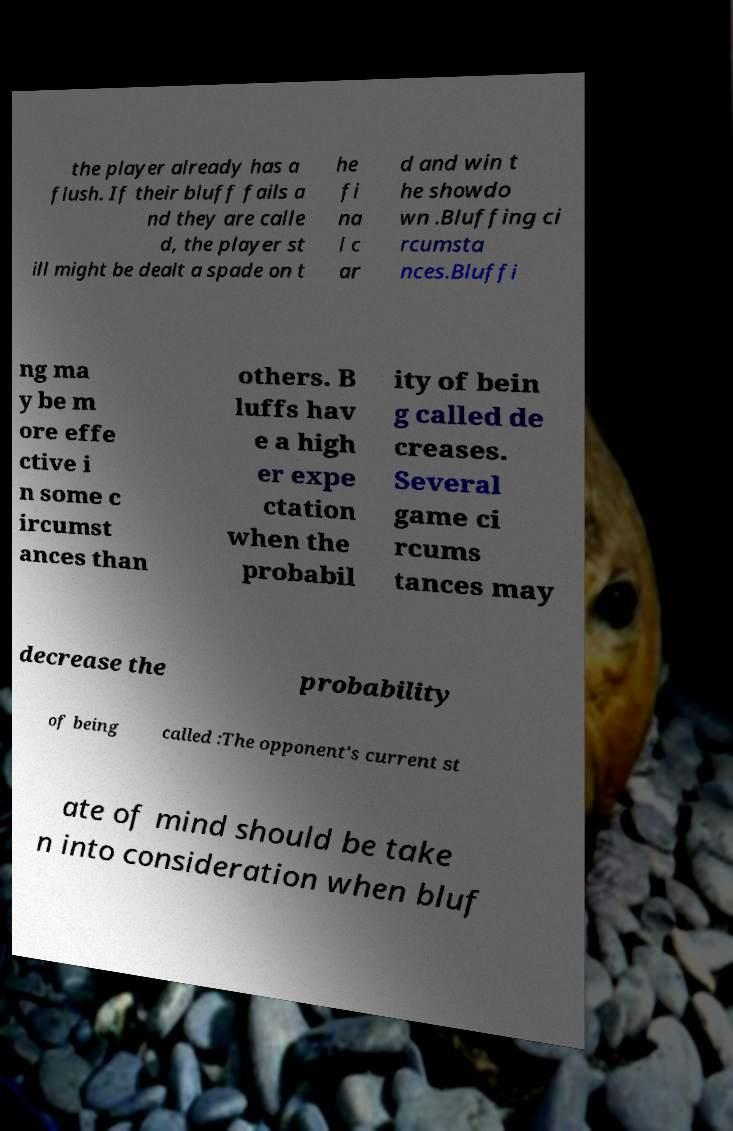Can you read and provide the text displayed in the image?This photo seems to have some interesting text. Can you extract and type it out for me? the player already has a flush. If their bluff fails a nd they are calle d, the player st ill might be dealt a spade on t he fi na l c ar d and win t he showdo wn .Bluffing ci rcumsta nces.Bluffi ng ma y be m ore effe ctive i n some c ircumst ances than others. B luffs hav e a high er expe ctation when the probabil ity of bein g called de creases. Several game ci rcums tances may decrease the probability of being called :The opponent's current st ate of mind should be take n into consideration when bluf 